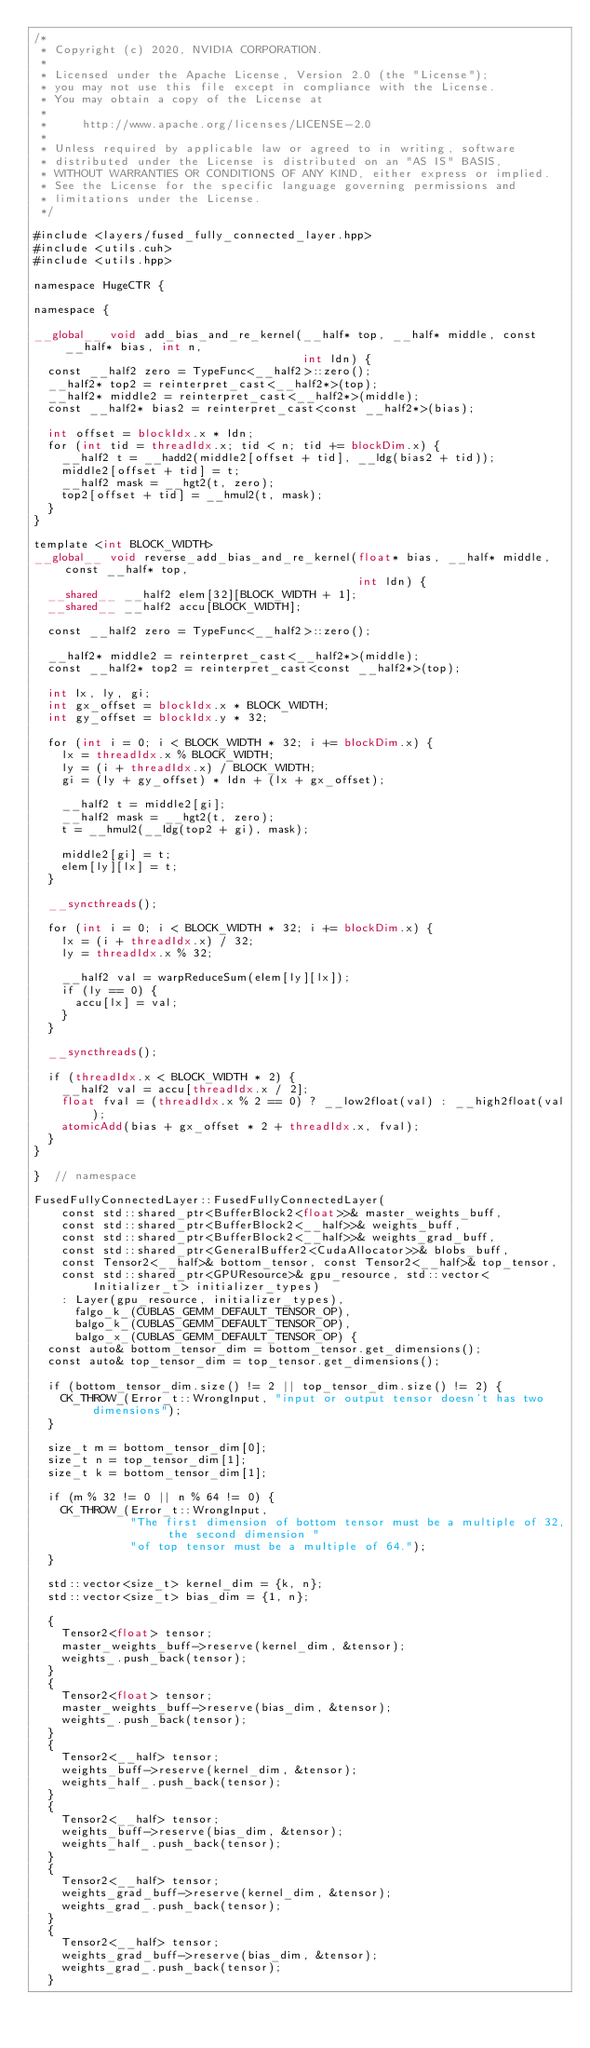Convert code to text. <code><loc_0><loc_0><loc_500><loc_500><_Cuda_>/*
 * Copyright (c) 2020, NVIDIA CORPORATION.
 *
 * Licensed under the Apache License, Version 2.0 (the "License");
 * you may not use this file except in compliance with the License.
 * You may obtain a copy of the License at
 *
 *     http://www.apache.org/licenses/LICENSE-2.0
 *
 * Unless required by applicable law or agreed to in writing, software
 * distributed under the License is distributed on an "AS IS" BASIS,
 * WITHOUT WARRANTIES OR CONDITIONS OF ANY KIND, either express or implied.
 * See the License for the specific language governing permissions and
 * limitations under the License.
 */

#include <layers/fused_fully_connected_layer.hpp>
#include <utils.cuh>
#include <utils.hpp>

namespace HugeCTR {

namespace {

__global__ void add_bias_and_re_kernel(__half* top, __half* middle, const __half* bias, int n,
                                       int ldn) {
  const __half2 zero = TypeFunc<__half2>::zero();
  __half2* top2 = reinterpret_cast<__half2*>(top);
  __half2* middle2 = reinterpret_cast<__half2*>(middle);
  const __half2* bias2 = reinterpret_cast<const __half2*>(bias);

  int offset = blockIdx.x * ldn;
  for (int tid = threadIdx.x; tid < n; tid += blockDim.x) {
    __half2 t = __hadd2(middle2[offset + tid], __ldg(bias2 + tid));
    middle2[offset + tid] = t;
    __half2 mask = __hgt2(t, zero);
    top2[offset + tid] = __hmul2(t, mask);
  }
}

template <int BLOCK_WIDTH>
__global__ void reverse_add_bias_and_re_kernel(float* bias, __half* middle, const __half* top,
                                               int ldn) {
  __shared__ __half2 elem[32][BLOCK_WIDTH + 1];
  __shared__ __half2 accu[BLOCK_WIDTH];

  const __half2 zero = TypeFunc<__half2>::zero();

  __half2* middle2 = reinterpret_cast<__half2*>(middle);
  const __half2* top2 = reinterpret_cast<const __half2*>(top);

  int lx, ly, gi;
  int gx_offset = blockIdx.x * BLOCK_WIDTH;
  int gy_offset = blockIdx.y * 32;

  for (int i = 0; i < BLOCK_WIDTH * 32; i += blockDim.x) {
    lx = threadIdx.x % BLOCK_WIDTH;
    ly = (i + threadIdx.x) / BLOCK_WIDTH;
    gi = (ly + gy_offset) * ldn + (lx + gx_offset);

    __half2 t = middle2[gi];
    __half2 mask = __hgt2(t, zero);
    t = __hmul2(__ldg(top2 + gi), mask);

    middle2[gi] = t;
    elem[ly][lx] = t;
  }

  __syncthreads();

  for (int i = 0; i < BLOCK_WIDTH * 32; i += blockDim.x) {
    lx = (i + threadIdx.x) / 32;
    ly = threadIdx.x % 32;

    __half2 val = warpReduceSum(elem[ly][lx]);
    if (ly == 0) {
      accu[lx] = val;
    }
  }

  __syncthreads();

  if (threadIdx.x < BLOCK_WIDTH * 2) {
    __half2 val = accu[threadIdx.x / 2];
    float fval = (threadIdx.x % 2 == 0) ? __low2float(val) : __high2float(val);
    atomicAdd(bias + gx_offset * 2 + threadIdx.x, fval);
  }
}

}  // namespace

FusedFullyConnectedLayer::FusedFullyConnectedLayer(
    const std::shared_ptr<BufferBlock2<float>>& master_weights_buff,
    const std::shared_ptr<BufferBlock2<__half>>& weights_buff,
    const std::shared_ptr<BufferBlock2<__half>>& weights_grad_buff,
    const std::shared_ptr<GeneralBuffer2<CudaAllocator>>& blobs_buff,
    const Tensor2<__half>& bottom_tensor, const Tensor2<__half>& top_tensor,
    const std::shared_ptr<GPUResource>& gpu_resource, std::vector<Initializer_t> initializer_types)
    : Layer(gpu_resource, initializer_types),
      falgo_k_(CUBLAS_GEMM_DEFAULT_TENSOR_OP),
      balgo_k_(CUBLAS_GEMM_DEFAULT_TENSOR_OP),
      balgo_x_(CUBLAS_GEMM_DEFAULT_TENSOR_OP) {
  const auto& bottom_tensor_dim = bottom_tensor.get_dimensions();
  const auto& top_tensor_dim = top_tensor.get_dimensions();

  if (bottom_tensor_dim.size() != 2 || top_tensor_dim.size() != 2) {
    CK_THROW_(Error_t::WrongInput, "input or output tensor doesn't has two dimensions");
  }

  size_t m = bottom_tensor_dim[0];
  size_t n = top_tensor_dim[1];
  size_t k = bottom_tensor_dim[1];

  if (m % 32 != 0 || n % 64 != 0) {
    CK_THROW_(Error_t::WrongInput,
              "The first dimension of bottom tensor must be a multiple of 32, the second dimension "
              "of top tensor must be a multiple of 64.");
  }

  std::vector<size_t> kernel_dim = {k, n};
  std::vector<size_t> bias_dim = {1, n};

  {
    Tensor2<float> tensor;
    master_weights_buff->reserve(kernel_dim, &tensor);
    weights_.push_back(tensor);
  }
  {
    Tensor2<float> tensor;
    master_weights_buff->reserve(bias_dim, &tensor);
    weights_.push_back(tensor);
  }
  {
    Tensor2<__half> tensor;
    weights_buff->reserve(kernel_dim, &tensor);
    weights_half_.push_back(tensor);
  }
  {
    Tensor2<__half> tensor;
    weights_buff->reserve(bias_dim, &tensor);
    weights_half_.push_back(tensor);
  }
  {
    Tensor2<__half> tensor;
    weights_grad_buff->reserve(kernel_dim, &tensor);
    weights_grad_.push_back(tensor);
  }
  {
    Tensor2<__half> tensor;
    weights_grad_buff->reserve(bias_dim, &tensor);
    weights_grad_.push_back(tensor);
  }
</code> 